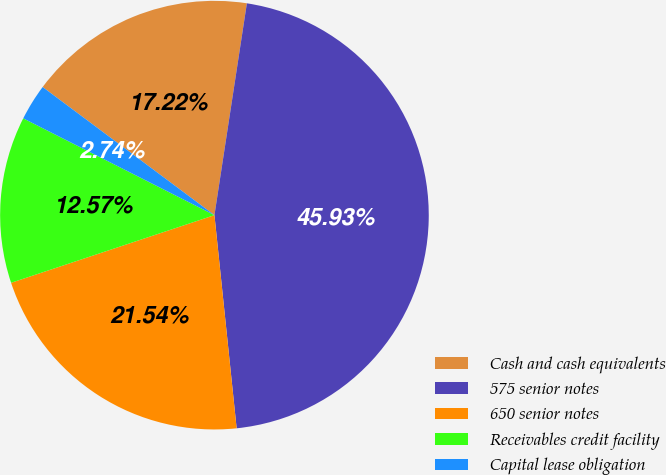Convert chart to OTSL. <chart><loc_0><loc_0><loc_500><loc_500><pie_chart><fcel>Cash and cash equivalents<fcel>575 senior notes<fcel>650 senior notes<fcel>Receivables credit facility<fcel>Capital lease obligation<nl><fcel>17.22%<fcel>45.93%<fcel>21.54%<fcel>12.57%<fcel>2.74%<nl></chart> 